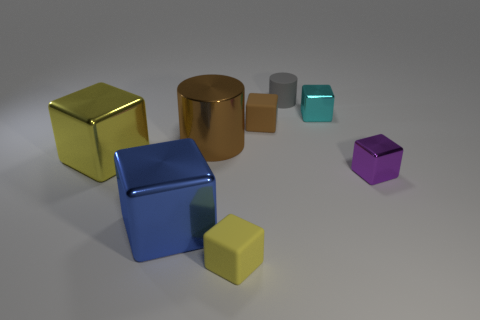Are there any small purple blocks made of the same material as the blue object?
Provide a succinct answer. Yes. The other rubber object that is the same shape as the yellow rubber object is what color?
Your answer should be very brief. Brown. Do the tiny gray cylinder and the cylinder that is left of the small gray rubber cylinder have the same material?
Provide a short and direct response. No. What is the shape of the brown thing on the right side of the matte object that is in front of the metal cylinder?
Ensure brevity in your answer.  Cube. Is the size of the shiny object behind the brown metallic cylinder the same as the small yellow cube?
Ensure brevity in your answer.  Yes. How many other things are there of the same shape as the cyan thing?
Your response must be concise. 5. There is a cylinder on the left side of the tiny gray cylinder; is it the same color as the small rubber cylinder?
Your answer should be very brief. No. Are there any large metallic blocks of the same color as the small matte cylinder?
Your answer should be very brief. No. How many things are behind the purple thing?
Keep it short and to the point. 5. What number of other things are there of the same size as the brown matte object?
Your answer should be compact. 4. 